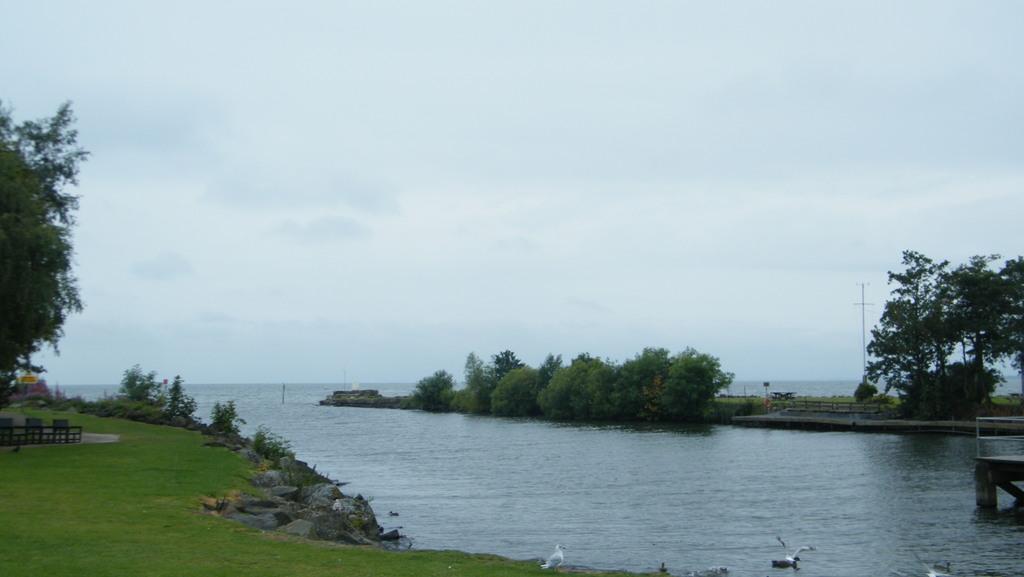Please provide a concise description of this image. In this image, we can see the sea, few plants, trees, grass, stones, rods, wooden objects. Here we can see few birds. Background there is a sky. 